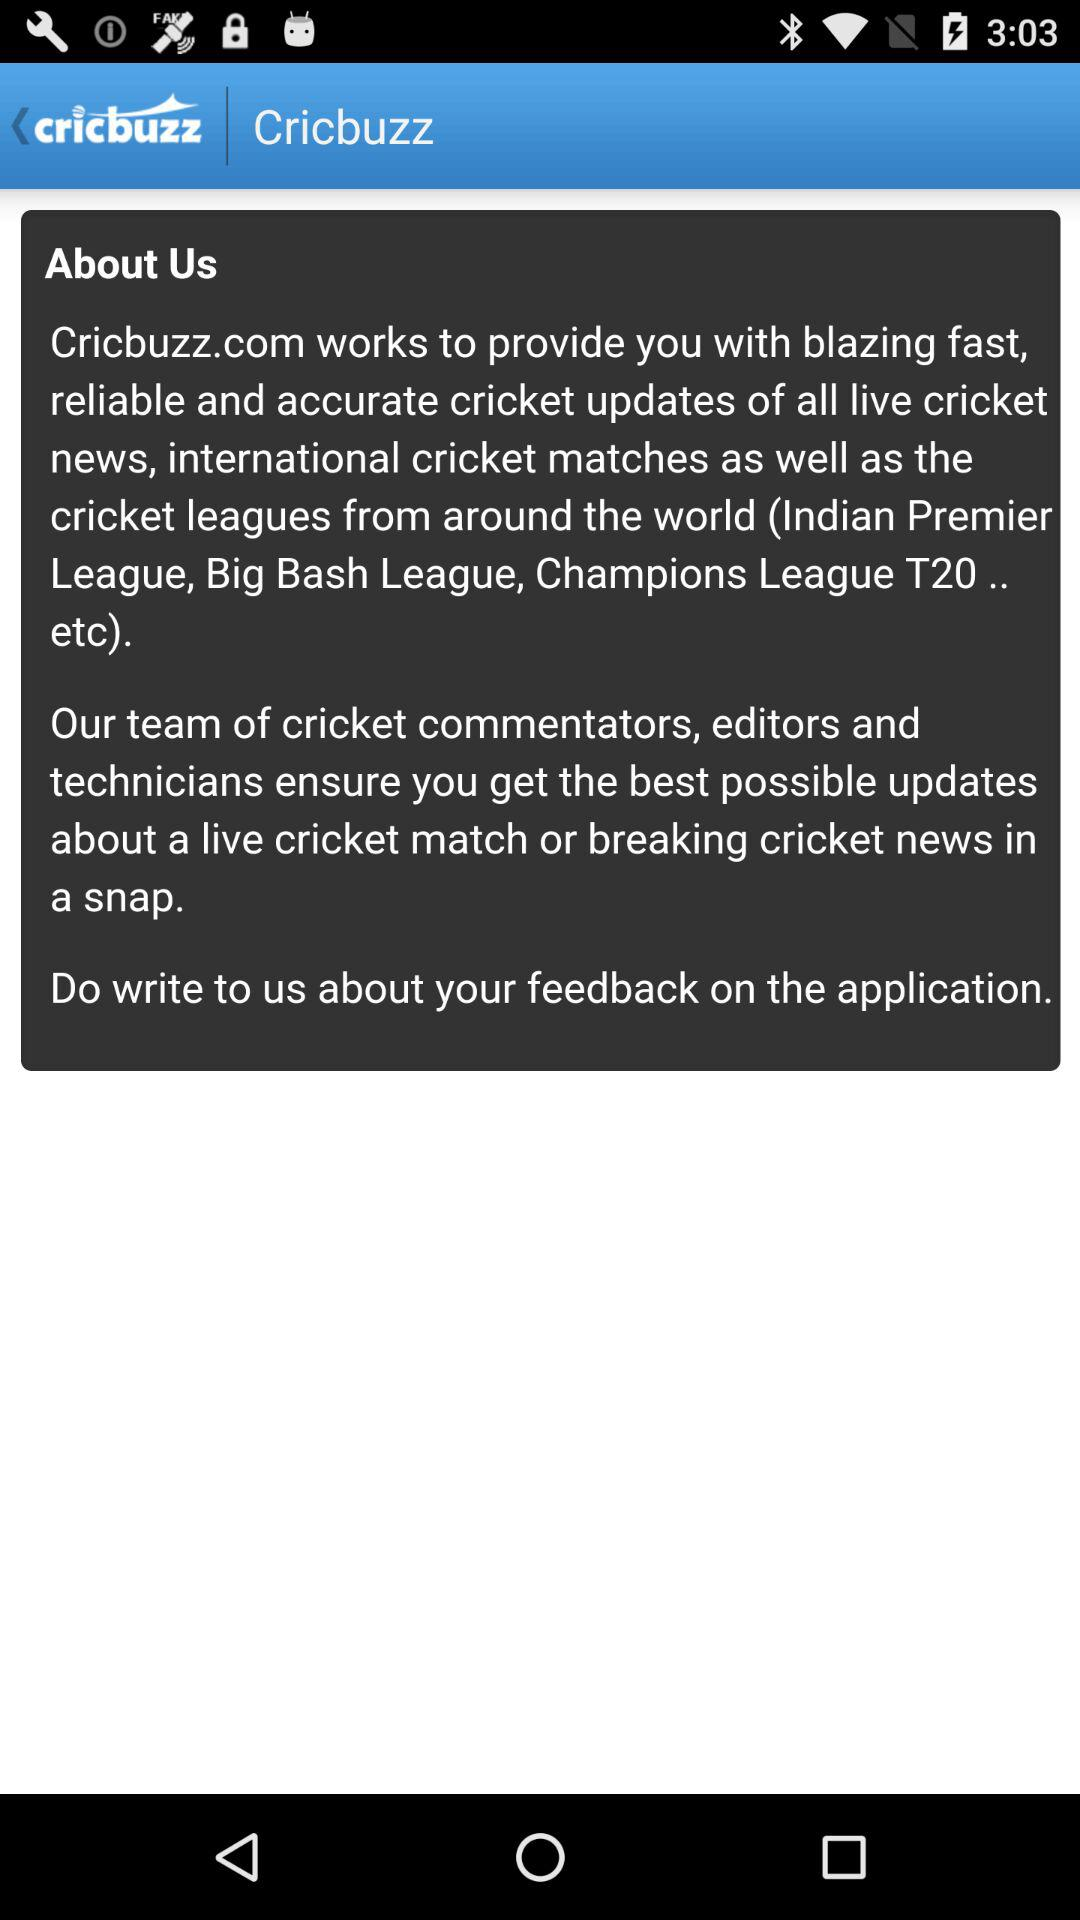What is the name of the application? The name of the application is "Cricbuzz". 